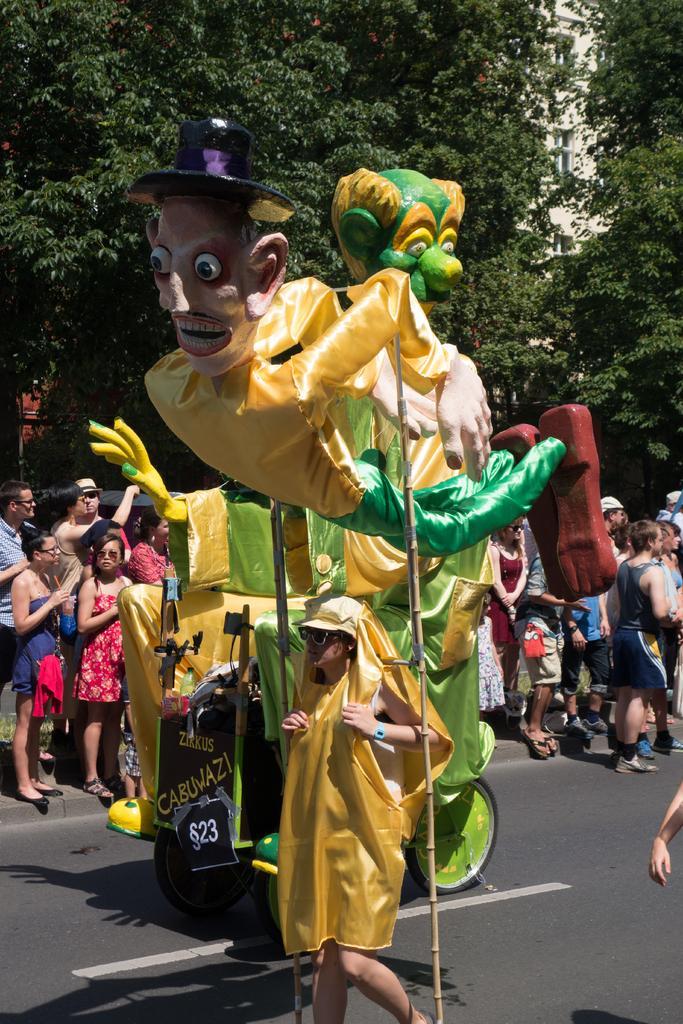Could you give a brief overview of what you see in this image? In this image a person wearing goggles and cap is walking on the road along with puppet which is attached to the sticks. Beside there is a puppet on the vehicle which is on the road. Behind few persons are standing. Background there are few trees. Right side a person hand is visible. 